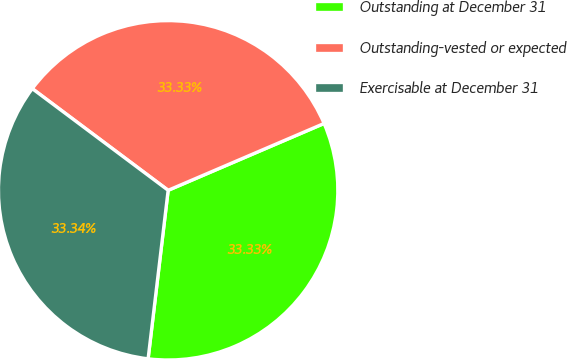Convert chart to OTSL. <chart><loc_0><loc_0><loc_500><loc_500><pie_chart><fcel>Outstanding at December 31<fcel>Outstanding-vested or expected<fcel>Exercisable at December 31<nl><fcel>33.33%<fcel>33.33%<fcel>33.34%<nl></chart> 